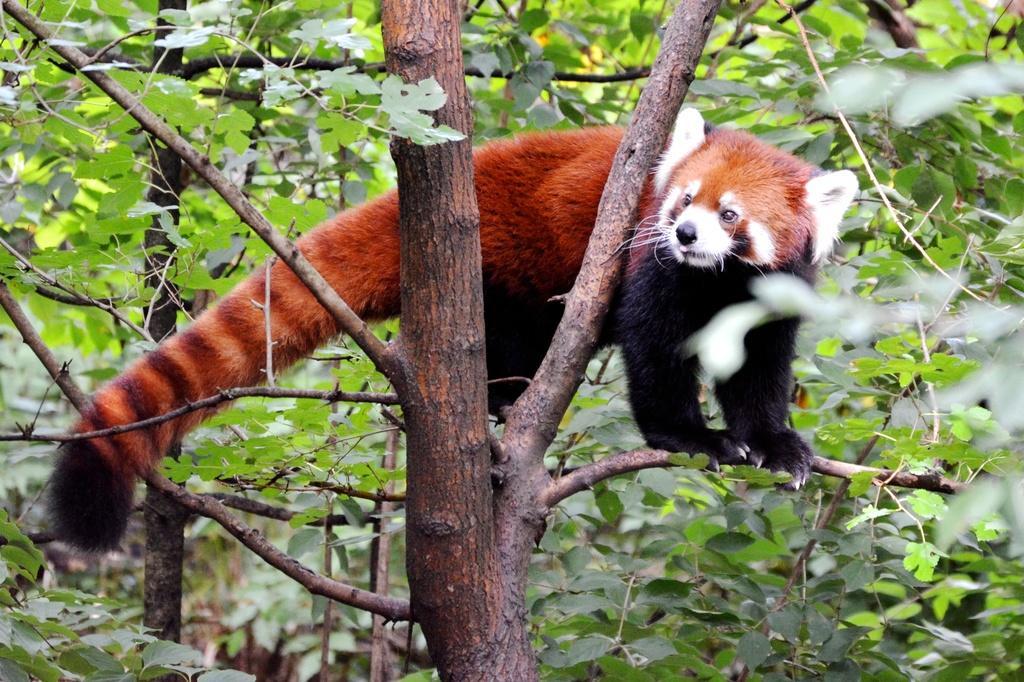Describe this image in one or two sentences. In this image we can see there is an animal on the tree. 